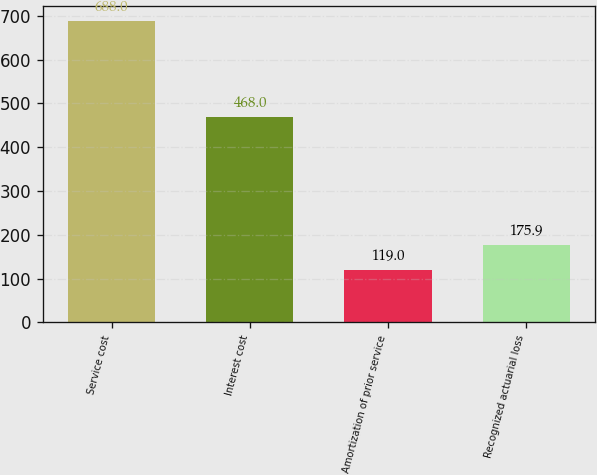<chart> <loc_0><loc_0><loc_500><loc_500><bar_chart><fcel>Service cost<fcel>Interest cost<fcel>Amortization of prior service<fcel>Recognized actuarial loss<nl><fcel>688<fcel>468<fcel>119<fcel>175.9<nl></chart> 